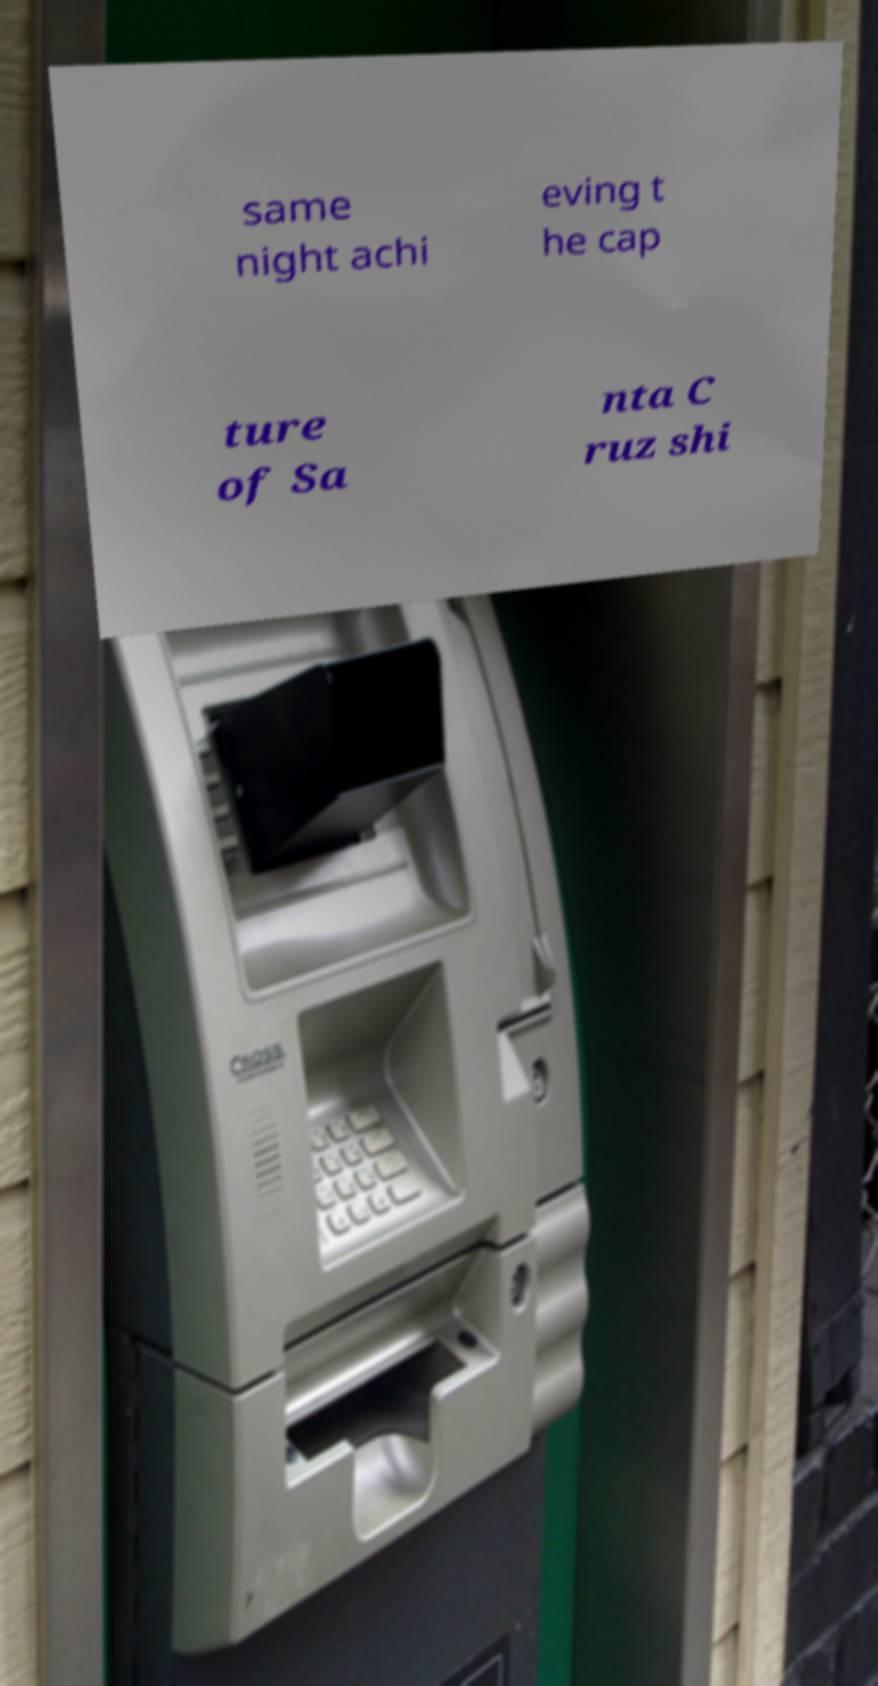I need the written content from this picture converted into text. Can you do that? same night achi eving t he cap ture of Sa nta C ruz shi 